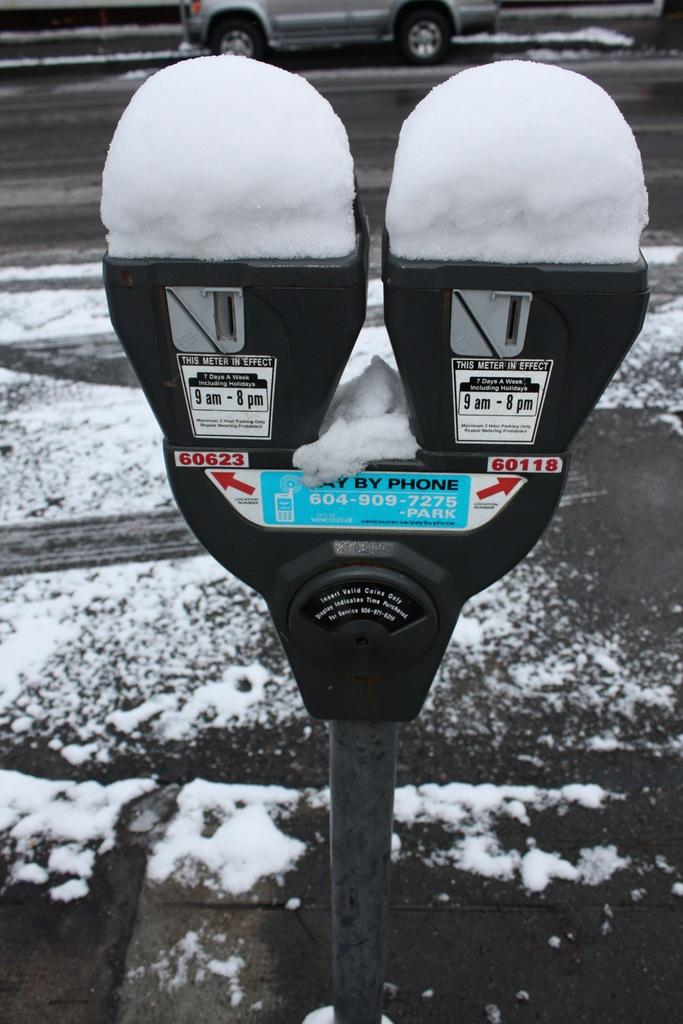<image>
Render a clear and concise summary of the photo. With these parking meters you can pay by phone 